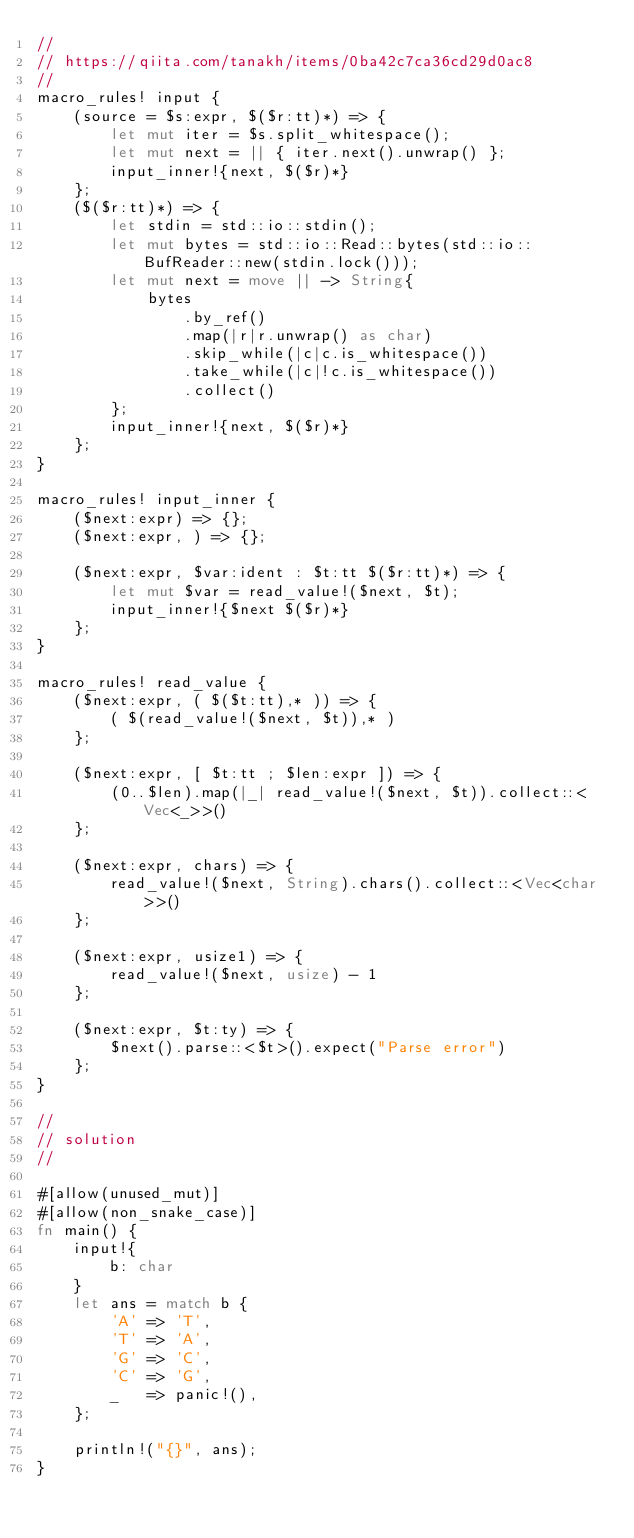<code> <loc_0><loc_0><loc_500><loc_500><_Rust_>//
// https://qiita.com/tanakh/items/0ba42c7ca36cd29d0ac8
//
macro_rules! input {
    (source = $s:expr, $($r:tt)*) => {
        let mut iter = $s.split_whitespace();
        let mut next = || { iter.next().unwrap() };
        input_inner!{next, $($r)*}
    };
    ($($r:tt)*) => {
        let stdin = std::io::stdin();
        let mut bytes = std::io::Read::bytes(std::io::BufReader::new(stdin.lock()));
        let mut next = move || -> String{
            bytes
                .by_ref()
                .map(|r|r.unwrap() as char)
                .skip_while(|c|c.is_whitespace())
                .take_while(|c|!c.is_whitespace())
                .collect()
        };
        input_inner!{next, $($r)*}
    };
}

macro_rules! input_inner {
    ($next:expr) => {};
    ($next:expr, ) => {};

    ($next:expr, $var:ident : $t:tt $($r:tt)*) => {
        let mut $var = read_value!($next, $t);
        input_inner!{$next $($r)*}
    };
}

macro_rules! read_value {
    ($next:expr, ( $($t:tt),* )) => {
        ( $(read_value!($next, $t)),* )
    };

    ($next:expr, [ $t:tt ; $len:expr ]) => {
        (0..$len).map(|_| read_value!($next, $t)).collect::<Vec<_>>()
    };

    ($next:expr, chars) => {
        read_value!($next, String).chars().collect::<Vec<char>>()
    };

    ($next:expr, usize1) => {
        read_value!($next, usize) - 1
    };

    ($next:expr, $t:ty) => {
        $next().parse::<$t>().expect("Parse error")
    };
}

//
// solution 
//

#[allow(unused_mut)]
#[allow(non_snake_case)]
fn main() {
    input!{
        b: char
    }
    let ans = match b {
        'A' => 'T',
        'T' => 'A',
        'G' => 'C',
        'C' => 'G',
        _   => panic!(),
    };

    println!("{}", ans);
}
</code> 